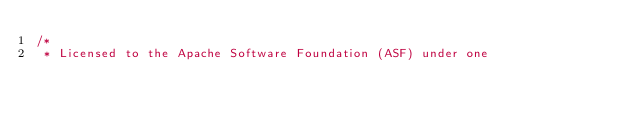<code> <loc_0><loc_0><loc_500><loc_500><_Java_>/*
 * Licensed to the Apache Software Foundation (ASF) under one</code> 